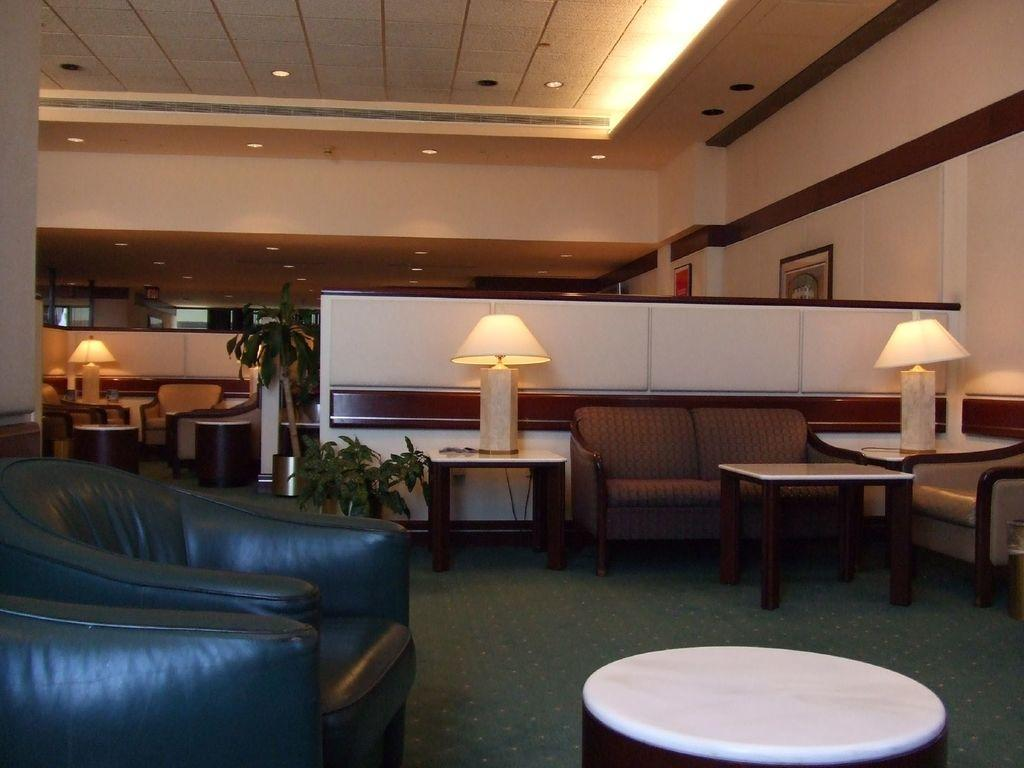What type of structure can be seen in the image? There is a wall in the image. What decorative item is present on the wall? There is a photo frame in the image. What type of living organism is in the image? There is a plant in the image. What type of lighting is present in the image? There are lamps in the image. What type of furniture is present in the image? There are tables, a sofa, and chairs in the image. What note is the plant playing in the image? There is no note being played in the image, as plants do not have the ability to play music. What belief is depicted in the photo frame in the image? There is no indication of any beliefs being depicted in the photo frame in the image. What type of teeth can be seen in the image? There are no teeth visible in the image. 